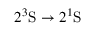<formula> <loc_0><loc_0><loc_500><loc_500>2 ^ { 3 } S \rightarrow 2 ^ { 1 } S</formula> 